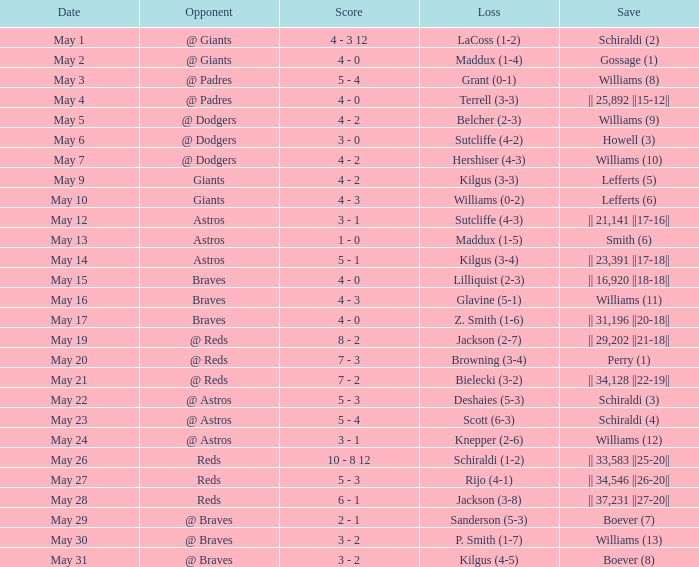What was the save for the braves on may 15th? || 16,920 ||18-18||. 